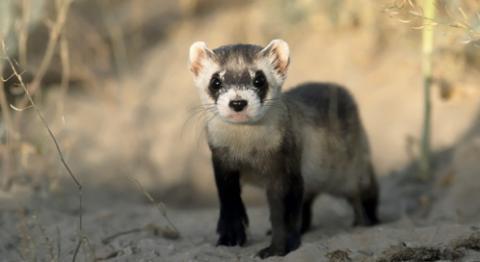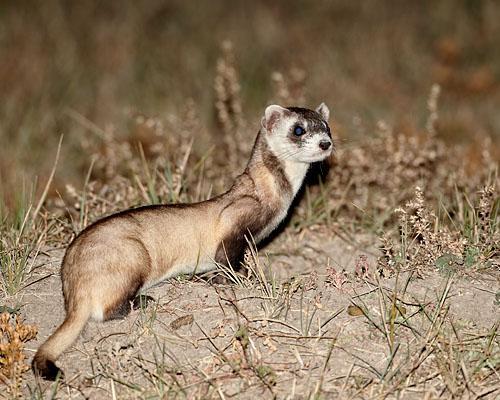The first image is the image on the left, the second image is the image on the right. For the images displayed, is the sentence "The left image contains no more than one ferret." factually correct? Answer yes or no. Yes. The first image is the image on the left, the second image is the image on the right. For the images shown, is this caption "There are exactly two ferrets." true? Answer yes or no. Yes. 